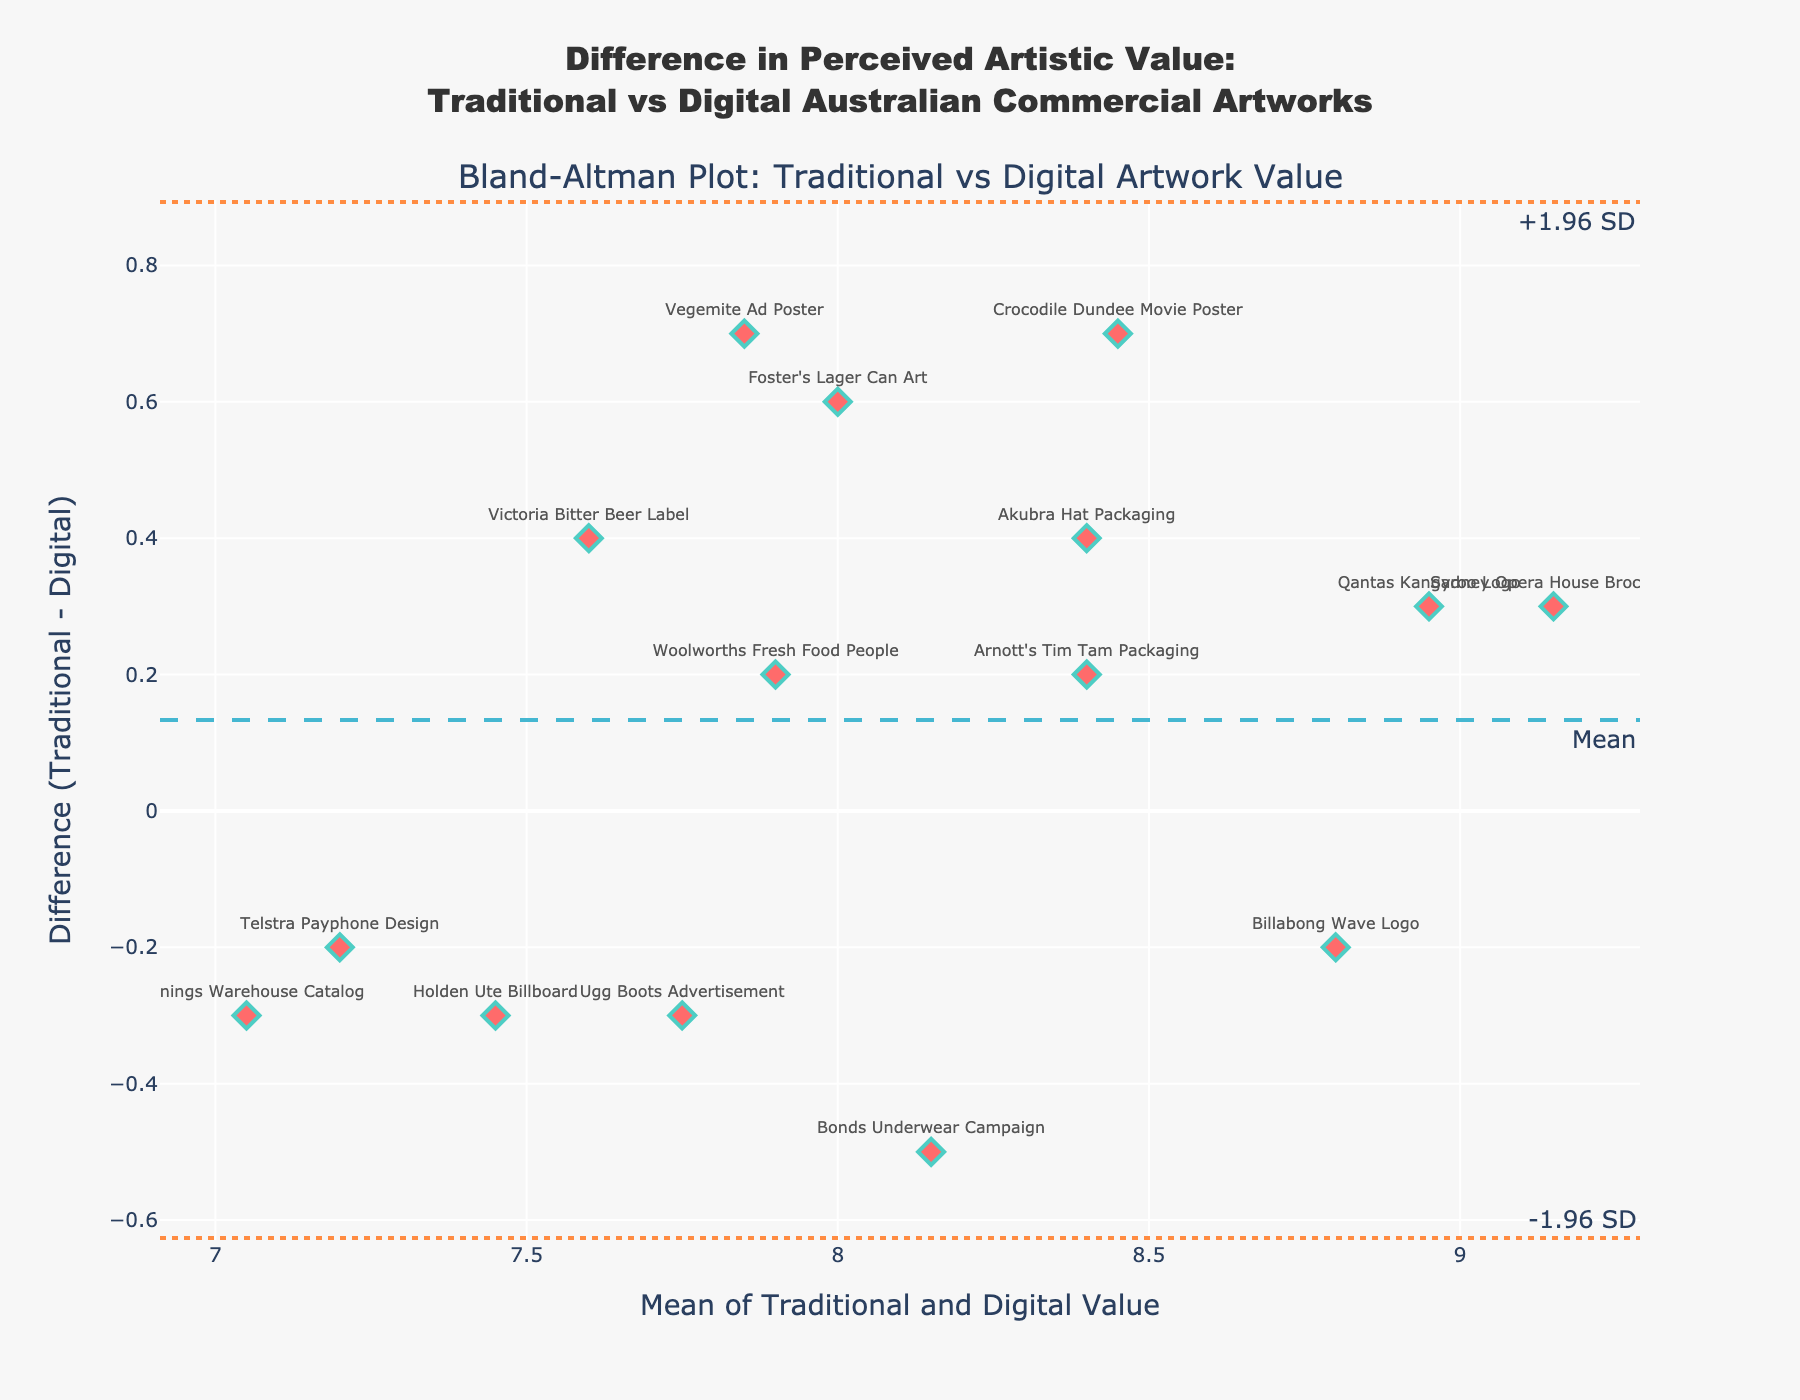what is the title of the plot? The title is located at the top of the plot and usually provides a brief description of what the plot represents. It helps in understanding the overall context of the plot at a glance.
Answer: "Difference in Perceived Artistic Value: Traditional vs Digital Australian Commercial Artworks" How many data points are displayed in the plot? Count the number of individual markers (diamonds) on the plot. Each diamond represents a data point corresponding to an artwork.
Answer: 15 What is the mean difference in perceived artistic value between traditional and digital artworks? Locate the horizontal dash line labeled as "Mean". The y-coordinate of this line represents the mean difference.
Answer: Approximately 0.13 Which artwork shows the largest difference in favor of traditional value? The largest difference in favor of traditional value will be the data point with the highest positive y-value (difference) above the mean line. Look for the artwork label attached to this point.
Answer: "Crocodile Dundee Movie Poster" What are the lower and upper limits of agreement? Locate the two dotted lines labeled as "+1.96 SD" and "-1.96 SD". The y-coordinates of these lines represent the upper and lower limits of agreement.
Answer: Approximately 1.04 and -0.79 Which two artworks have nearly the same mean value but differ significantly in their perceived values? Identify pairs of data points that are close together along the x-axis (mean value) but have significantly different y-coordinates (differences). Check the labels for these pairs.
Answer: "Holden Ute Billboard" and "Vegemite Ad Poster" What is the range of mean values on the x-axis? Observe the minimum and maximum values on the x-axis, which represent the range of the mean values of traditional and digital value scores.
Answer: Approximately 7.05 to 9.15 Which artwork has a higher digital value compared to its traditional value? These will be the points below the mean line (y=0) with negative y-values (differences). Locate the labels attached to the lowest points below the mean line.
Answer: "Bonds Underwear Campaign" How does the variability in differences compare for artworks with lower mean values versus higher mean values? Observe if the spread of data points in terms of differences (y-values) is more or less consistent across different mean values (x-axis) or if it changes. Check the distribution of points along the y-axis at different segments of the x-axis.
Answer: Differences are more consistent at higher mean values What does the position of the mean difference line tell us about the overall perception of traditional vs digital values across the artworks? The mean difference line indicates the average difference in value perception between traditional and digital artworks. If the line is above zero, traditional artworks are generally rated higher, and if it is below zero, digital artworks are rated higher.
Answer: Traditional artworks generally rated slightly higher Which artwork has a mean value closest to 8.15? Find the data point on the plot whose x-coordinate (mean value) is closest to 8.15 and locate the label attached to it.
Answer: "Arnott's Tim Tam Packaging" 